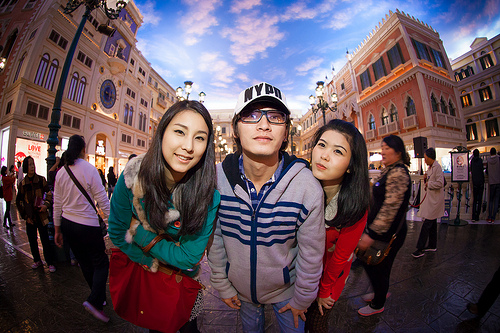<image>
Can you confirm if the bag is in front of the girl? Yes. The bag is positioned in front of the girl, appearing closer to the camera viewpoint. 